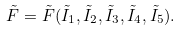<formula> <loc_0><loc_0><loc_500><loc_500>\tilde { F } = \tilde { F } ( \tilde { I } _ { 1 } , \tilde { I } _ { 2 } , \tilde { I } _ { 3 } , \tilde { I } _ { 4 } , \tilde { I } _ { 5 } ) .</formula> 